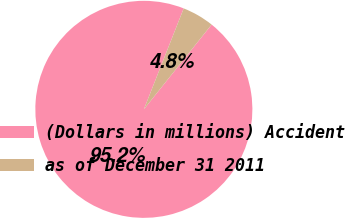Convert chart. <chart><loc_0><loc_0><loc_500><loc_500><pie_chart><fcel>(Dollars in millions) Accident<fcel>as of December 31 2011<nl><fcel>95.25%<fcel>4.75%<nl></chart> 